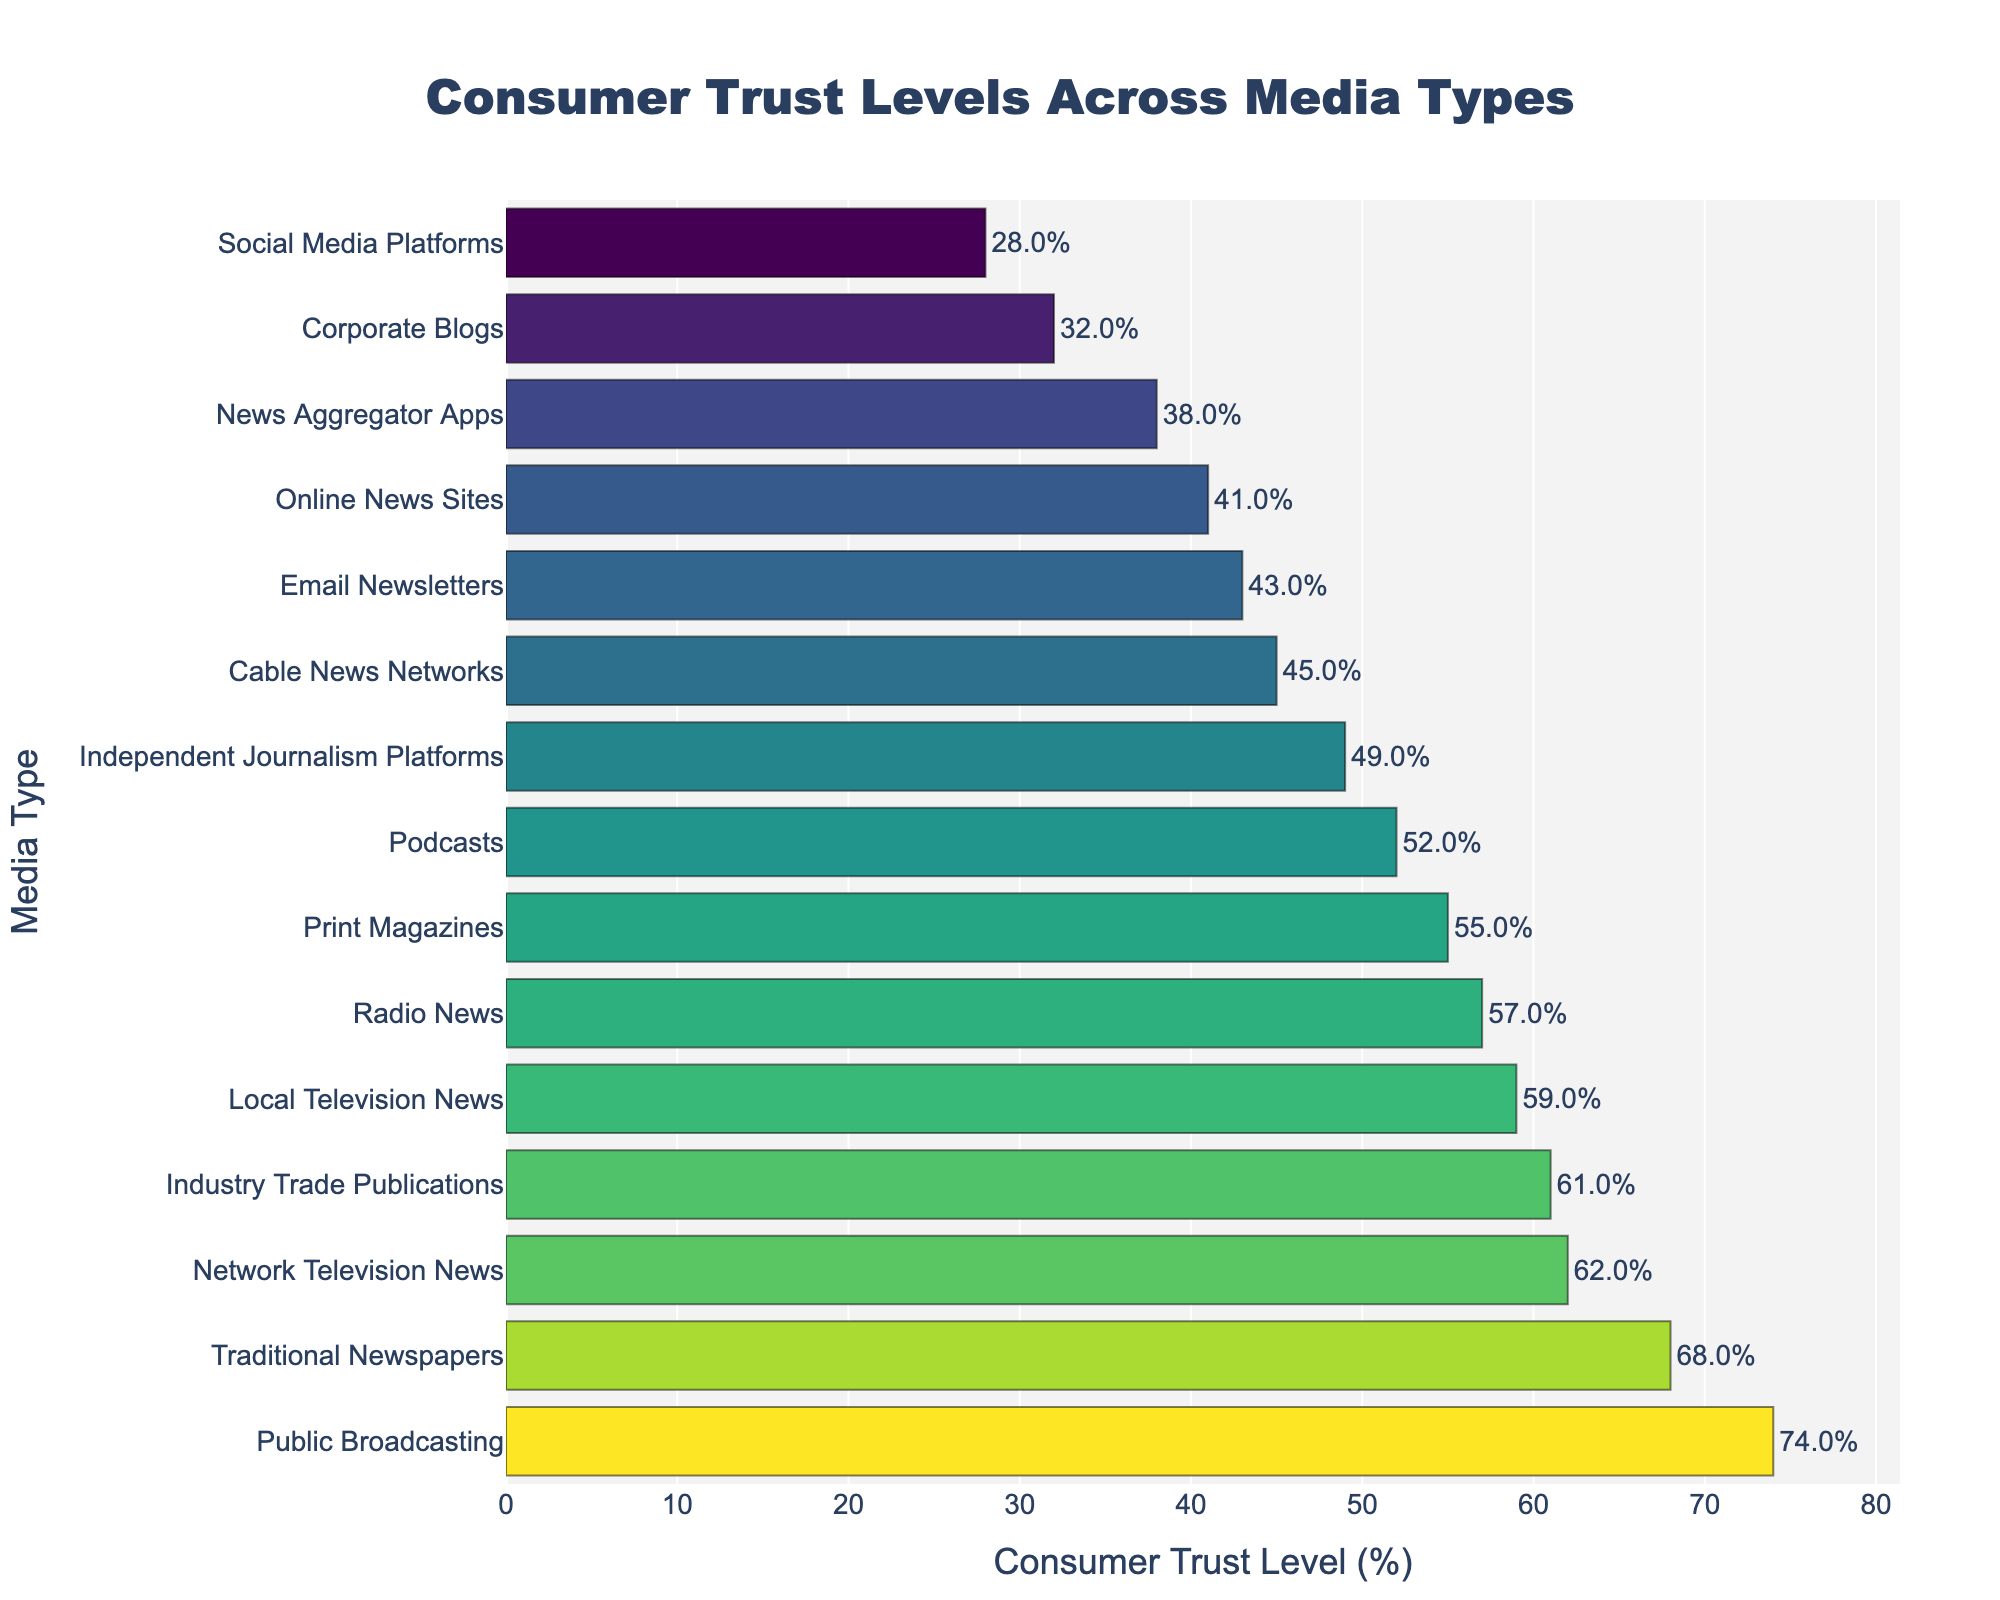What media type has the highest consumer trust level? The bar representing 'Public Broadcasting' is the tallest and positioned at the top, indicating it has the highest consumer trust level at 74%.
Answer: Public Broadcasting What is the trust level difference between Traditional Newspapers and Online News Sites? Traditional Newspapers have a trust level of 68%, while Online News Sites have 41%. The difference is calculated by subtracting 41 from 68.
Answer: 27% How many media types have a consumer trust level over 60%? The media types with trust levels over 60% are Public Broadcasting (74%), Traditional Newspapers (68%), Network Television News (62%), and Industry Trade Publications (61%). Count them.
Answer: 4 Which media type has a higher trust level, Cable News Networks or Podcasts? Comparing the bars for Cable News Networks (45%) and Podcasts (52%), the bar for Podcasts is higher.
Answer: Podcasts What is the average trust level for Corporate Blogs, Social Media Platforms, and Email Newsletters? Adding the trust levels of Corporate Blogs (32%), Social Media Platforms (28%), and Email Newsletters (43%) gives 103. Dividing by 3 yields the average trust level.
Answer: 34.33% What is the least trusted media type? The shortest bar in the chart represents Social Media Platforms, with a trust level of 28%.
Answer: Social Media Platforms Is the consumer trust level of Independent Journalism Platforms closer to Cable News Networks or Online News Sites? Independent Journalism Platforms have a trust level of 49%. Cable News Networks have 45%, and Online News Sites have 41%. The difference with Cable News Networks is 4%, and with Online News Sites, it is 8%.
Answer: Cable News Networks Compare the total trust level percentage of Radio News and Print Magazines with Network Television News and Public Broadcasting. Which group has a higher combined trust level? Adding the trust levels of Radio News (57%) and Print Magazines (55%) yields 112%. Adding the trust levels of Network Television News (62%) and Public Broadcasting (74%) yields 136%.
Answer: Network Television News and Public Broadcasting What is the difference in consumer trust levels between Industry Trade Publications and the two least trusted media types combined? Industry Trade Publications have a trust level of 61%. The two least trusted media types are Social Media Platforms (28%) and Online News Sites (41%). Adding their trust levels yields 69%. The difference is 69% - 61%.
Answer: 8% Which media type has a higher trust level than Print Magazines but lower than Public Broadcasting? Comparing the trust levels, Network Television News (62%) and Traditional Newspapers (68%) are higher than Print Magazines (55%) but lower than Public Broadcasting (74%).
Answer: Network Television News or Traditional Newspapers 